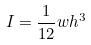Convert formula to latex. <formula><loc_0><loc_0><loc_500><loc_500>I = \frac { 1 } { 1 2 } w h ^ { 3 }</formula> 